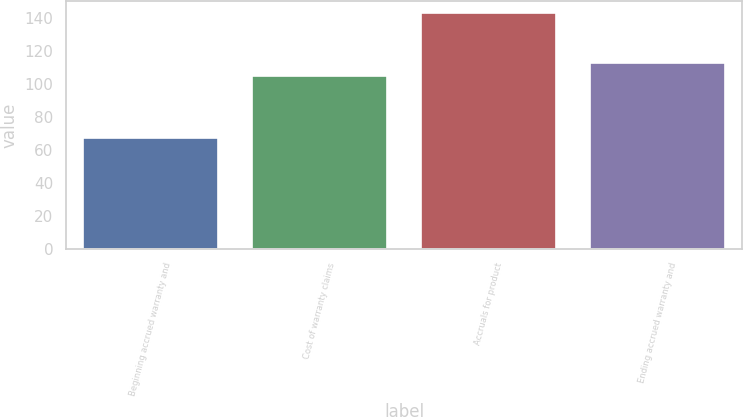Convert chart to OTSL. <chart><loc_0><loc_0><loc_500><loc_500><bar_chart><fcel>Beginning accrued warranty and<fcel>Cost of warranty claims<fcel>Accruals for product<fcel>Ending accrued warranty and<nl><fcel>67<fcel>105<fcel>143<fcel>112.6<nl></chart> 